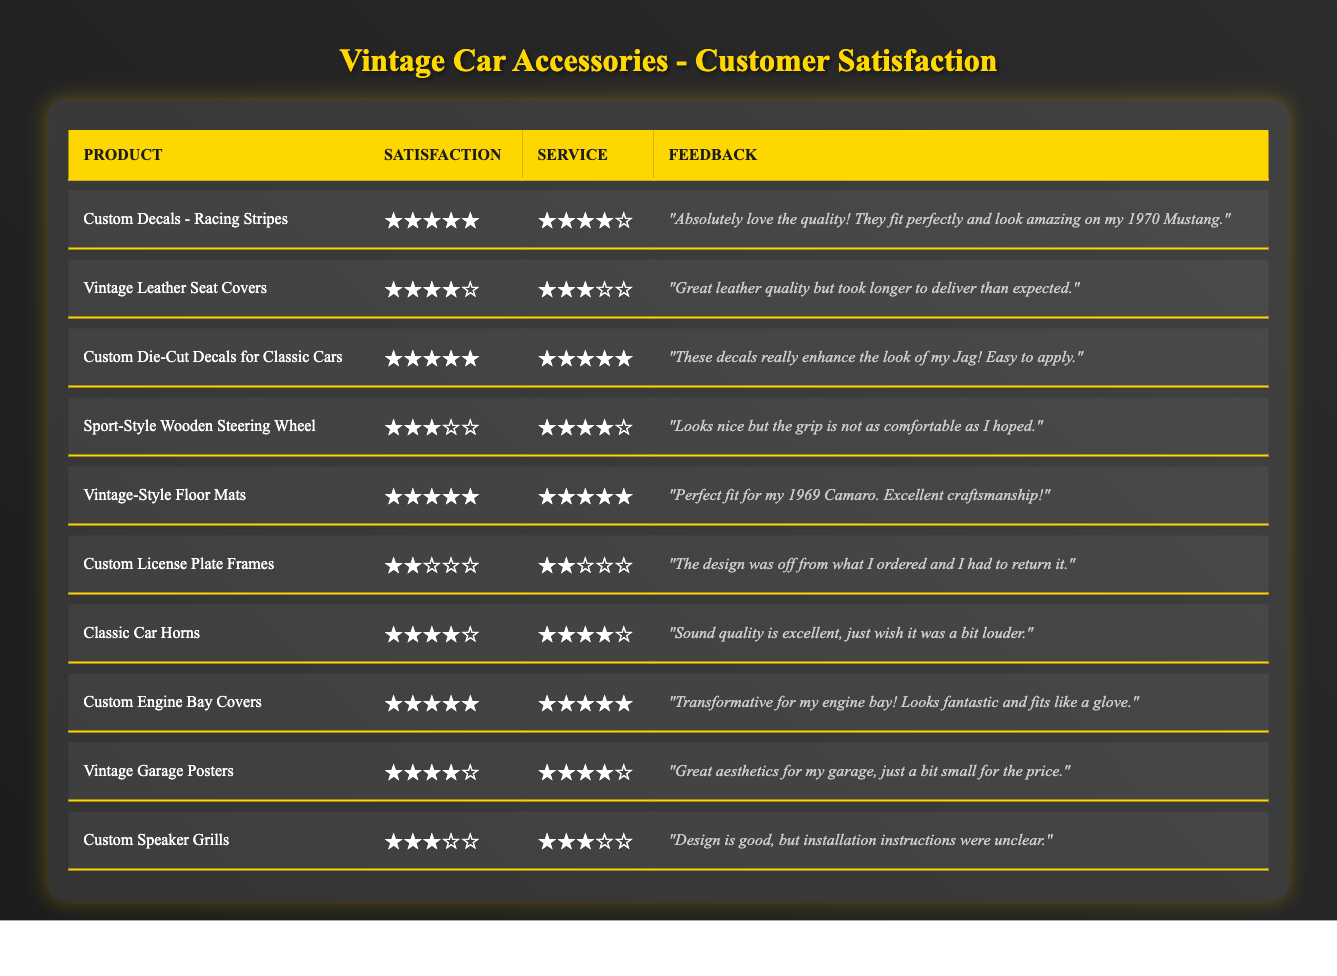What is the satisfaction rating for the "Custom Die-Cut Decals for Classic Cars"? The table lists the satisfaction rating for this product, which is explicitly noted as 5 stars.
Answer: 5 Which product received the lowest satisfaction rating? By examining the ratings in the table, the "Custom License Plate Frames" has a satisfaction rating of 2 stars, which is the lowest among all products.
Answer: Custom License Plate Frames What is the average service rating for all products? The service ratings are 4, 3, 5, 4, 5, 2, 4, 5, 4, and 3. Adding these together gives 43, and dividing by 10 (the number of products) results in an average service rating of 4.3.
Answer: 4.3 Did any product receive a satisfaction rating of 4 stars? Yes, the table shows that multiple products including "Vintage Leather Seat Covers" and "Classic Car Horns" received a satisfaction rating of 4 stars.
Answer: Yes Which product has both the highest satisfaction and service ratings? The "Custom Die-Cut Decals for Classic Cars" and "Vintage-Style Floor Mats" both have 5 stars for satisfaction and service ratings, making them the highest rated products in both categories.
Answer: Custom Die-Cut Decals for Classic Cars and Vintage-Style Floor Mats What is the total number of products rated below 4 stars? The products rated below 4 stars are "Custom License Plate Frames" (2 stars) and "Sport-Style Wooden Steering Wheel" (3 stars). Thus, there are 2 products rated below 4 stars.
Answer: 2 Which feedback mentions the delivery time? The feedback for the "Vintage Leather Seat Covers" mentions that it took longer to deliver than expected.
Answer: Vintage Leather Seat Covers How many products have a satisfaction rating of 5 stars? Upon reviewing the table, the products with a 5-star rating are "Custom Decals - Racing Stripes", "Custom Die-Cut Decals for Classic Cars", "Vintage-Style Floor Mats", "Custom Engine Bay Covers" totaling 4 products.
Answer: 4 